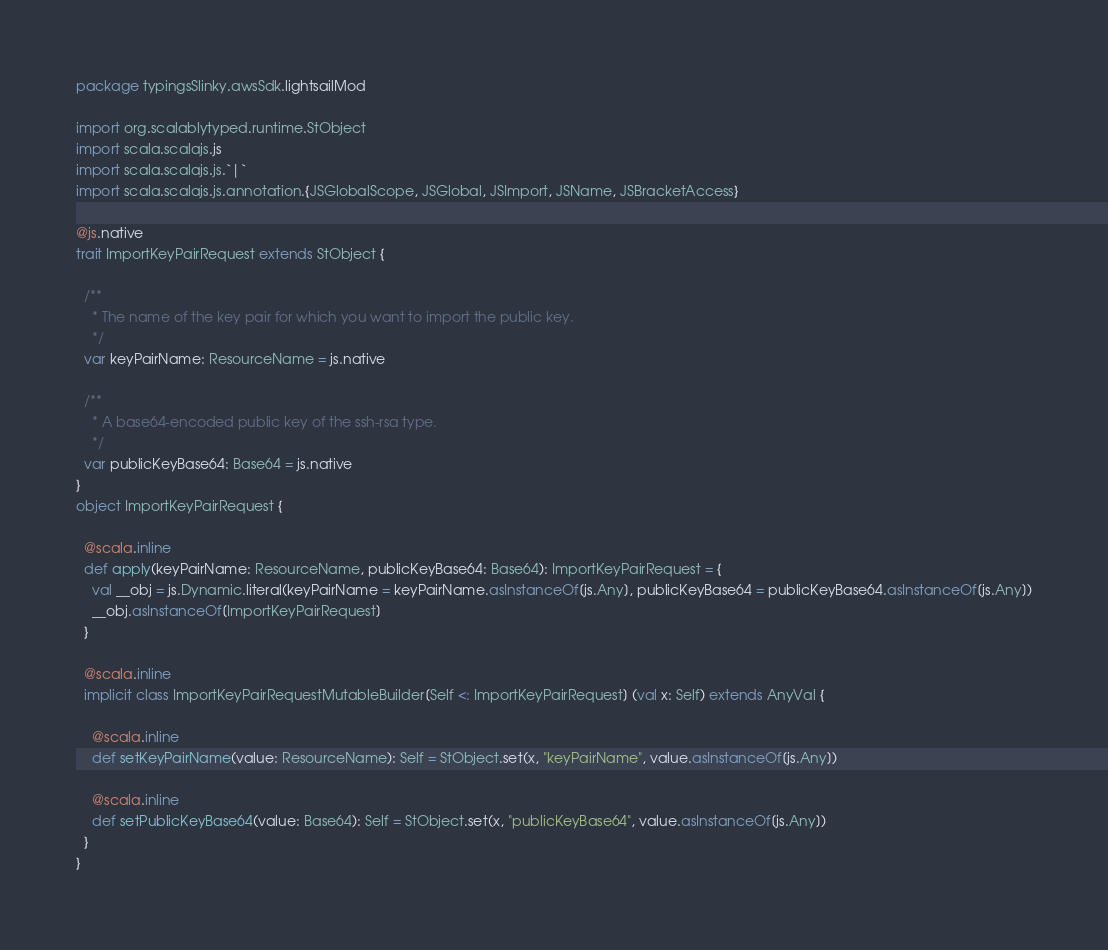Convert code to text. <code><loc_0><loc_0><loc_500><loc_500><_Scala_>package typingsSlinky.awsSdk.lightsailMod

import org.scalablytyped.runtime.StObject
import scala.scalajs.js
import scala.scalajs.js.`|`
import scala.scalajs.js.annotation.{JSGlobalScope, JSGlobal, JSImport, JSName, JSBracketAccess}

@js.native
trait ImportKeyPairRequest extends StObject {
  
  /**
    * The name of the key pair for which you want to import the public key.
    */
  var keyPairName: ResourceName = js.native
  
  /**
    * A base64-encoded public key of the ssh-rsa type.
    */
  var publicKeyBase64: Base64 = js.native
}
object ImportKeyPairRequest {
  
  @scala.inline
  def apply(keyPairName: ResourceName, publicKeyBase64: Base64): ImportKeyPairRequest = {
    val __obj = js.Dynamic.literal(keyPairName = keyPairName.asInstanceOf[js.Any], publicKeyBase64 = publicKeyBase64.asInstanceOf[js.Any])
    __obj.asInstanceOf[ImportKeyPairRequest]
  }
  
  @scala.inline
  implicit class ImportKeyPairRequestMutableBuilder[Self <: ImportKeyPairRequest] (val x: Self) extends AnyVal {
    
    @scala.inline
    def setKeyPairName(value: ResourceName): Self = StObject.set(x, "keyPairName", value.asInstanceOf[js.Any])
    
    @scala.inline
    def setPublicKeyBase64(value: Base64): Self = StObject.set(x, "publicKeyBase64", value.asInstanceOf[js.Any])
  }
}
</code> 